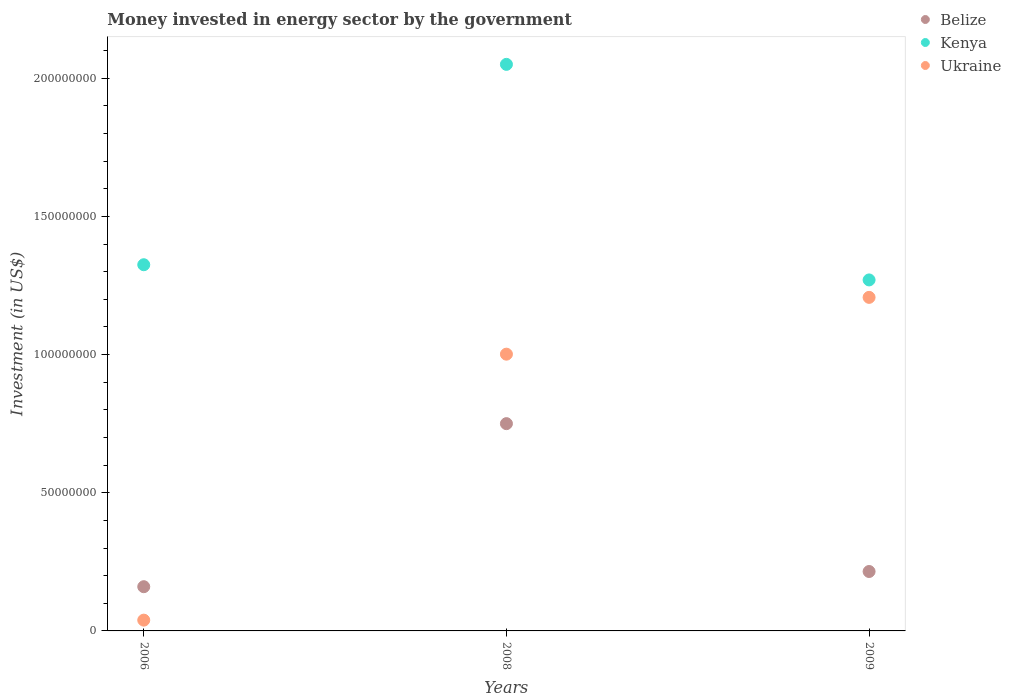How many different coloured dotlines are there?
Your answer should be very brief. 3. What is the money spent in energy sector in Belize in 2008?
Offer a very short reply. 7.50e+07. Across all years, what is the maximum money spent in energy sector in Kenya?
Your response must be concise. 2.05e+08. Across all years, what is the minimum money spent in energy sector in Kenya?
Provide a short and direct response. 1.27e+08. In which year was the money spent in energy sector in Ukraine maximum?
Your answer should be very brief. 2009. What is the total money spent in energy sector in Ukraine in the graph?
Your answer should be very brief. 2.25e+08. What is the difference between the money spent in energy sector in Ukraine in 2008 and that in 2009?
Your response must be concise. -2.06e+07. What is the difference between the money spent in energy sector in Belize in 2009 and the money spent in energy sector in Kenya in 2008?
Provide a short and direct response. -1.84e+08. What is the average money spent in energy sector in Kenya per year?
Offer a terse response. 1.55e+08. In the year 2009, what is the difference between the money spent in energy sector in Ukraine and money spent in energy sector in Belize?
Provide a short and direct response. 9.92e+07. What is the ratio of the money spent in energy sector in Belize in 2006 to that in 2009?
Make the answer very short. 0.74. Is the money spent in energy sector in Ukraine in 2008 less than that in 2009?
Provide a succinct answer. Yes. Is the difference between the money spent in energy sector in Ukraine in 2006 and 2009 greater than the difference between the money spent in energy sector in Belize in 2006 and 2009?
Make the answer very short. No. What is the difference between the highest and the second highest money spent in energy sector in Ukraine?
Give a very brief answer. 2.06e+07. What is the difference between the highest and the lowest money spent in energy sector in Ukraine?
Your answer should be very brief. 1.17e+08. Is the money spent in energy sector in Belize strictly greater than the money spent in energy sector in Ukraine over the years?
Offer a very short reply. No. Is the money spent in energy sector in Belize strictly less than the money spent in energy sector in Kenya over the years?
Make the answer very short. Yes. What is the difference between two consecutive major ticks on the Y-axis?
Your answer should be compact. 5.00e+07. Does the graph contain any zero values?
Offer a terse response. No. Where does the legend appear in the graph?
Offer a very short reply. Top right. How many legend labels are there?
Your answer should be very brief. 3. How are the legend labels stacked?
Offer a very short reply. Vertical. What is the title of the graph?
Ensure brevity in your answer.  Money invested in energy sector by the government. What is the label or title of the X-axis?
Offer a terse response. Years. What is the label or title of the Y-axis?
Offer a very short reply. Investment (in US$). What is the Investment (in US$) in Belize in 2006?
Provide a succinct answer. 1.60e+07. What is the Investment (in US$) of Kenya in 2006?
Ensure brevity in your answer.  1.32e+08. What is the Investment (in US$) in Ukraine in 2006?
Offer a terse response. 3.90e+06. What is the Investment (in US$) in Belize in 2008?
Provide a succinct answer. 7.50e+07. What is the Investment (in US$) of Kenya in 2008?
Make the answer very short. 2.05e+08. What is the Investment (in US$) in Ukraine in 2008?
Provide a succinct answer. 1.00e+08. What is the Investment (in US$) of Belize in 2009?
Give a very brief answer. 2.15e+07. What is the Investment (in US$) of Kenya in 2009?
Ensure brevity in your answer.  1.27e+08. What is the Investment (in US$) in Ukraine in 2009?
Your answer should be compact. 1.21e+08. Across all years, what is the maximum Investment (in US$) in Belize?
Offer a terse response. 7.50e+07. Across all years, what is the maximum Investment (in US$) of Kenya?
Ensure brevity in your answer.  2.05e+08. Across all years, what is the maximum Investment (in US$) in Ukraine?
Provide a short and direct response. 1.21e+08. Across all years, what is the minimum Investment (in US$) in Belize?
Provide a short and direct response. 1.60e+07. Across all years, what is the minimum Investment (in US$) in Kenya?
Provide a short and direct response. 1.27e+08. Across all years, what is the minimum Investment (in US$) of Ukraine?
Make the answer very short. 3.90e+06. What is the total Investment (in US$) of Belize in the graph?
Provide a succinct answer. 1.12e+08. What is the total Investment (in US$) in Kenya in the graph?
Keep it short and to the point. 4.64e+08. What is the total Investment (in US$) in Ukraine in the graph?
Offer a very short reply. 2.25e+08. What is the difference between the Investment (in US$) of Belize in 2006 and that in 2008?
Provide a succinct answer. -5.90e+07. What is the difference between the Investment (in US$) in Kenya in 2006 and that in 2008?
Keep it short and to the point. -7.25e+07. What is the difference between the Investment (in US$) of Ukraine in 2006 and that in 2008?
Provide a short and direct response. -9.62e+07. What is the difference between the Investment (in US$) in Belize in 2006 and that in 2009?
Keep it short and to the point. -5.50e+06. What is the difference between the Investment (in US$) in Kenya in 2006 and that in 2009?
Keep it short and to the point. 5.50e+06. What is the difference between the Investment (in US$) in Ukraine in 2006 and that in 2009?
Offer a very short reply. -1.17e+08. What is the difference between the Investment (in US$) of Belize in 2008 and that in 2009?
Provide a succinct answer. 5.35e+07. What is the difference between the Investment (in US$) of Kenya in 2008 and that in 2009?
Provide a short and direct response. 7.80e+07. What is the difference between the Investment (in US$) of Ukraine in 2008 and that in 2009?
Your answer should be compact. -2.06e+07. What is the difference between the Investment (in US$) of Belize in 2006 and the Investment (in US$) of Kenya in 2008?
Your answer should be very brief. -1.89e+08. What is the difference between the Investment (in US$) in Belize in 2006 and the Investment (in US$) in Ukraine in 2008?
Provide a succinct answer. -8.41e+07. What is the difference between the Investment (in US$) in Kenya in 2006 and the Investment (in US$) in Ukraine in 2008?
Make the answer very short. 3.24e+07. What is the difference between the Investment (in US$) in Belize in 2006 and the Investment (in US$) in Kenya in 2009?
Give a very brief answer. -1.11e+08. What is the difference between the Investment (in US$) of Belize in 2006 and the Investment (in US$) of Ukraine in 2009?
Your answer should be very brief. -1.05e+08. What is the difference between the Investment (in US$) of Kenya in 2006 and the Investment (in US$) of Ukraine in 2009?
Offer a very short reply. 1.18e+07. What is the difference between the Investment (in US$) in Belize in 2008 and the Investment (in US$) in Kenya in 2009?
Offer a terse response. -5.20e+07. What is the difference between the Investment (in US$) of Belize in 2008 and the Investment (in US$) of Ukraine in 2009?
Offer a terse response. -4.57e+07. What is the difference between the Investment (in US$) in Kenya in 2008 and the Investment (in US$) in Ukraine in 2009?
Keep it short and to the point. 8.43e+07. What is the average Investment (in US$) of Belize per year?
Keep it short and to the point. 3.75e+07. What is the average Investment (in US$) in Kenya per year?
Your answer should be compact. 1.55e+08. What is the average Investment (in US$) in Ukraine per year?
Provide a succinct answer. 7.49e+07. In the year 2006, what is the difference between the Investment (in US$) of Belize and Investment (in US$) of Kenya?
Ensure brevity in your answer.  -1.16e+08. In the year 2006, what is the difference between the Investment (in US$) in Belize and Investment (in US$) in Ukraine?
Your answer should be very brief. 1.21e+07. In the year 2006, what is the difference between the Investment (in US$) of Kenya and Investment (in US$) of Ukraine?
Your response must be concise. 1.29e+08. In the year 2008, what is the difference between the Investment (in US$) in Belize and Investment (in US$) in Kenya?
Your answer should be very brief. -1.30e+08. In the year 2008, what is the difference between the Investment (in US$) in Belize and Investment (in US$) in Ukraine?
Your answer should be very brief. -2.51e+07. In the year 2008, what is the difference between the Investment (in US$) of Kenya and Investment (in US$) of Ukraine?
Keep it short and to the point. 1.05e+08. In the year 2009, what is the difference between the Investment (in US$) in Belize and Investment (in US$) in Kenya?
Ensure brevity in your answer.  -1.06e+08. In the year 2009, what is the difference between the Investment (in US$) of Belize and Investment (in US$) of Ukraine?
Give a very brief answer. -9.92e+07. In the year 2009, what is the difference between the Investment (in US$) in Kenya and Investment (in US$) in Ukraine?
Provide a short and direct response. 6.31e+06. What is the ratio of the Investment (in US$) in Belize in 2006 to that in 2008?
Your response must be concise. 0.21. What is the ratio of the Investment (in US$) of Kenya in 2006 to that in 2008?
Your answer should be compact. 0.65. What is the ratio of the Investment (in US$) of Ukraine in 2006 to that in 2008?
Your response must be concise. 0.04. What is the ratio of the Investment (in US$) in Belize in 2006 to that in 2009?
Your response must be concise. 0.74. What is the ratio of the Investment (in US$) of Kenya in 2006 to that in 2009?
Provide a succinct answer. 1.04. What is the ratio of the Investment (in US$) in Ukraine in 2006 to that in 2009?
Give a very brief answer. 0.03. What is the ratio of the Investment (in US$) of Belize in 2008 to that in 2009?
Provide a short and direct response. 3.49. What is the ratio of the Investment (in US$) of Kenya in 2008 to that in 2009?
Your answer should be very brief. 1.61. What is the ratio of the Investment (in US$) in Ukraine in 2008 to that in 2009?
Your response must be concise. 0.83. What is the difference between the highest and the second highest Investment (in US$) of Belize?
Offer a terse response. 5.35e+07. What is the difference between the highest and the second highest Investment (in US$) of Kenya?
Your answer should be very brief. 7.25e+07. What is the difference between the highest and the second highest Investment (in US$) in Ukraine?
Your response must be concise. 2.06e+07. What is the difference between the highest and the lowest Investment (in US$) in Belize?
Give a very brief answer. 5.90e+07. What is the difference between the highest and the lowest Investment (in US$) in Kenya?
Ensure brevity in your answer.  7.80e+07. What is the difference between the highest and the lowest Investment (in US$) in Ukraine?
Provide a short and direct response. 1.17e+08. 